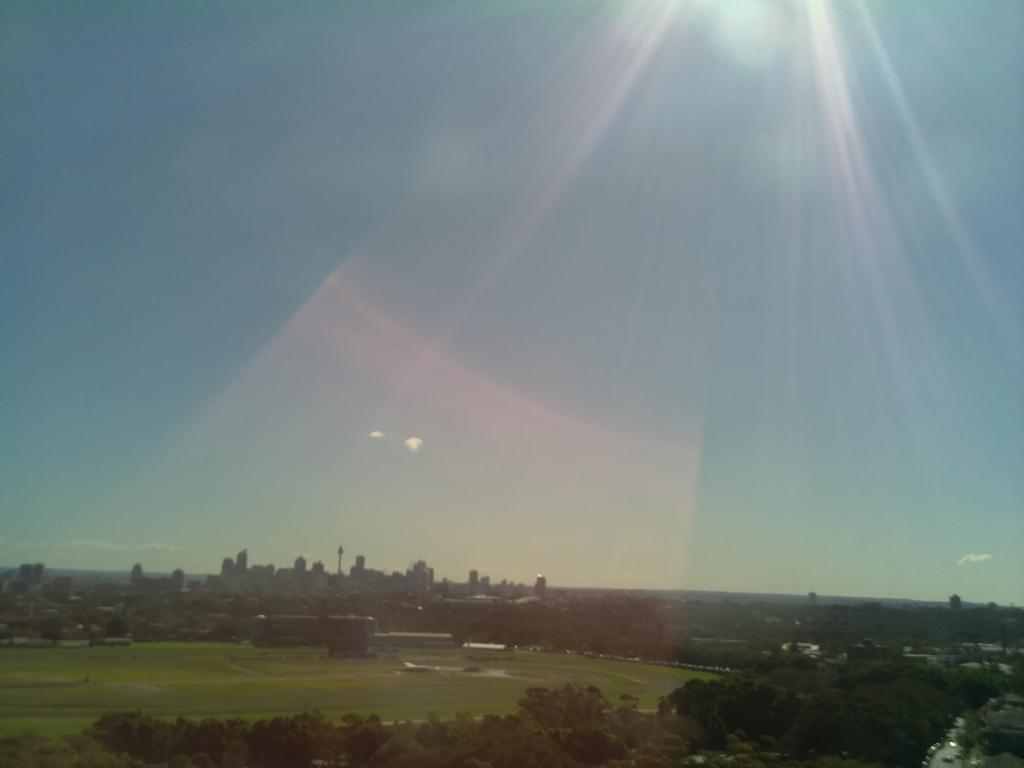What type of surface can be seen at the bottom of the image? There is ground visible in the image. What structure is present in the image? There is a stadium in the image. What type of vegetation is present at the bottom of the image? There are many trees at the bottom of the image. What can be seen in the background of the image? There is a tower, skyscrapers, and other buildings in the background of the image. What is visible at the top of the image? The sky is visible at the top of the image. How many baskets are being traded in the image? There are no baskets or trading activities depicted in the image. What type of twist can be seen in the image? There is no twist present in the image. 